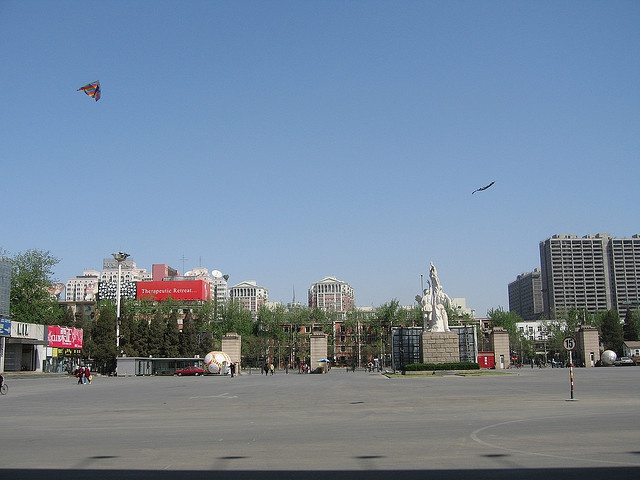Describe the objects in this image and their specific colors. I can see kite in gray, darkgray, and teal tones, car in gray, black, maroon, and brown tones, car in gray, black, and darkgray tones, people in gray, maroon, black, and tan tones, and people in gray, black, maroon, and darkgray tones in this image. 